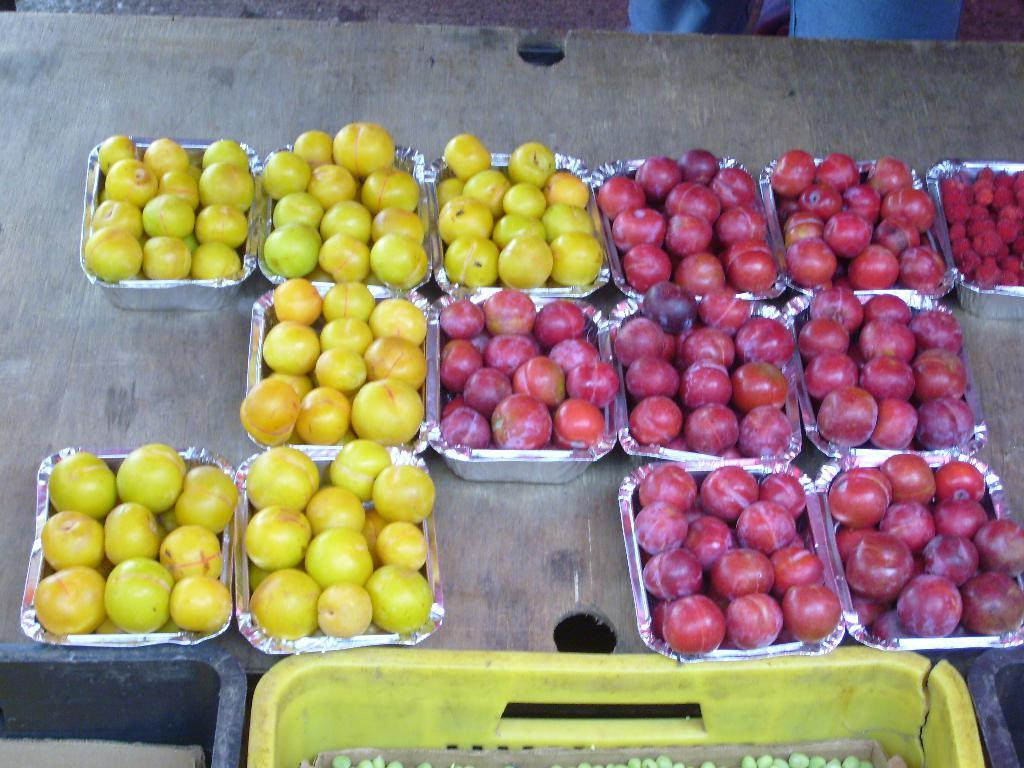What is contained in the boxes that are visible in the image? There are fruits in boxes in the image. Where are the boxes with fruits located? The boxes are present on a table. What type of containers are also visible in the image? There are plastic baskets present in the image. How does the rain affect the fruits in the image? There is no rain present in the image, so its effect on the fruits cannot be determined. 